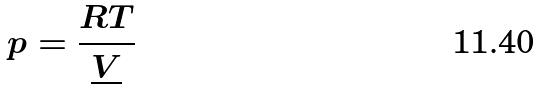<formula> <loc_0><loc_0><loc_500><loc_500>p = \frac { R T } { \underline { V } }</formula> 